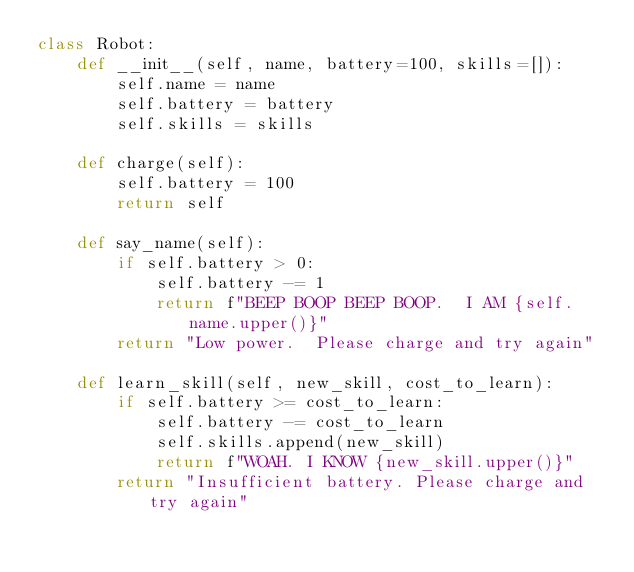Convert code to text. <code><loc_0><loc_0><loc_500><loc_500><_Python_>class Robot:
	def __init__(self, name, battery=100, skills=[]):
		self.name = name
		self.battery = battery
		self.skills = skills

	def charge(self):
		self.battery = 100
		return self

	def say_name(self):
		if self.battery > 0:
			self.battery -= 1
			return f"BEEP BOOP BEEP BOOP.  I AM {self.name.upper()}"
		return "Low power.  Please charge and try again"

	def learn_skill(self, new_skill, cost_to_learn):
		if self.battery >= cost_to_learn:
			self.battery -= cost_to_learn
			self.skills.append(new_skill)
			return f"WOAH. I KNOW {new_skill.upper()}"
		return "Insufficient battery. Please charge and try again"

		

</code> 